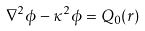Convert formula to latex. <formula><loc_0><loc_0><loc_500><loc_500>\nabla ^ { 2 } \phi - \kappa ^ { 2 } \phi = Q _ { 0 } ( r )</formula> 